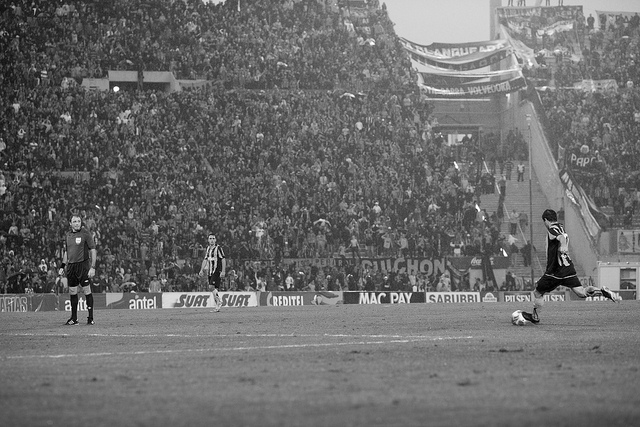Please identify all text content in this image. SUAT SUAT CREDITFI MAC PAY ARIAS at antel GUICHON SARURRI PAPr VOLVEDORA 